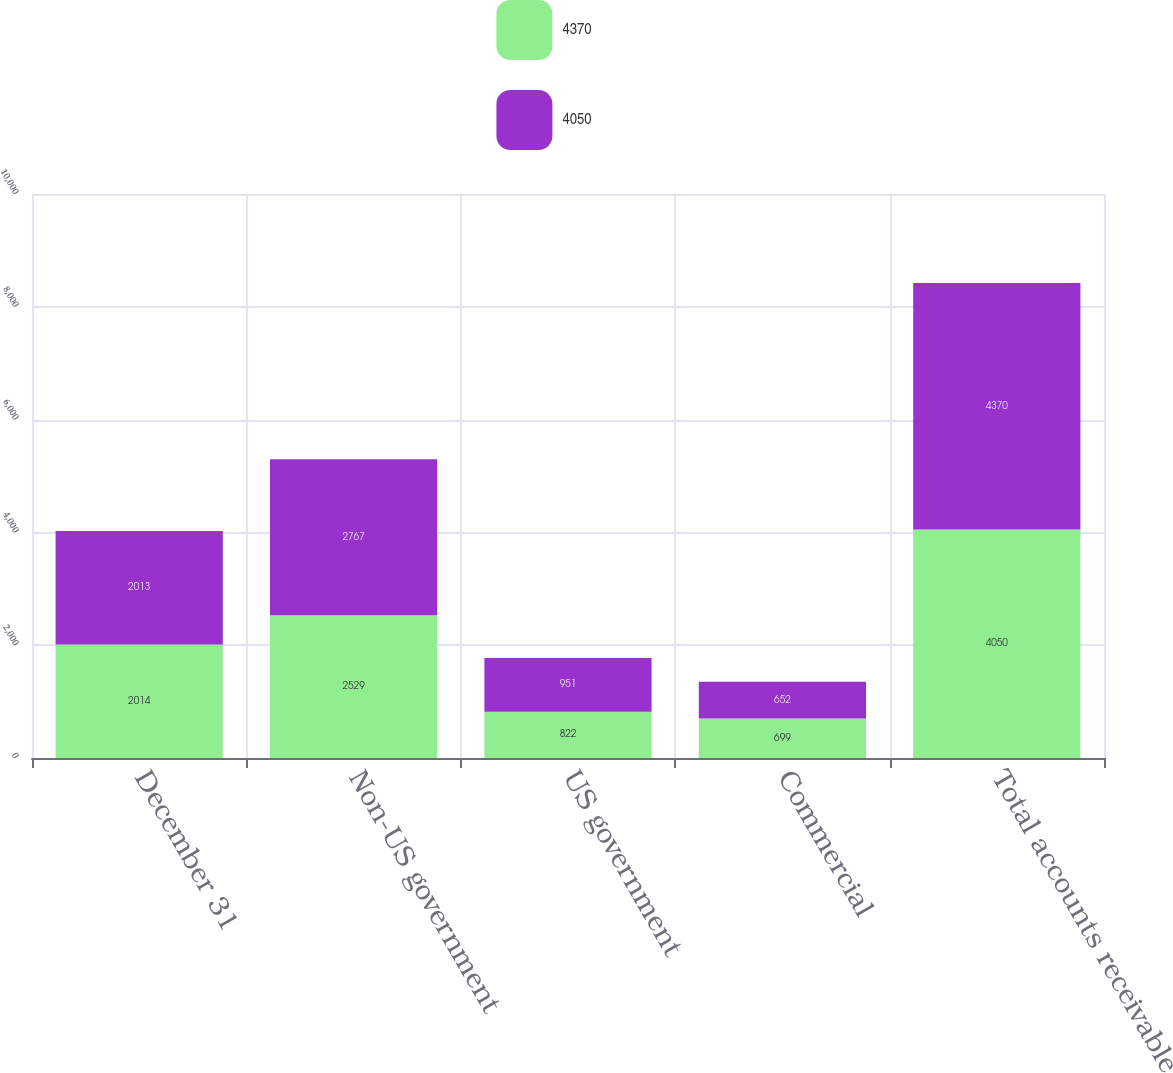<chart> <loc_0><loc_0><loc_500><loc_500><stacked_bar_chart><ecel><fcel>December 31<fcel>Non-US government<fcel>US government<fcel>Commercial<fcel>Total accounts receivable<nl><fcel>4370<fcel>2014<fcel>2529<fcel>822<fcel>699<fcel>4050<nl><fcel>4050<fcel>2013<fcel>2767<fcel>951<fcel>652<fcel>4370<nl></chart> 